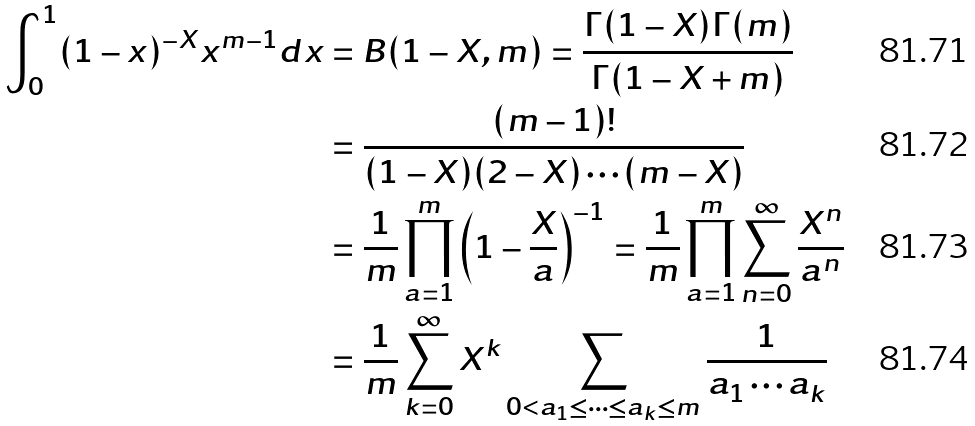<formula> <loc_0><loc_0><loc_500><loc_500>\int _ { 0 } ^ { 1 } ( 1 - x ) ^ { - X } x ^ { m - 1 } d x & = B ( 1 - X , m ) = \frac { \Gamma ( 1 - X ) \Gamma ( m ) } { \Gamma ( 1 - X + m ) } \\ & = \frac { ( m - 1 ) ! } { ( 1 - X ) ( 2 - X ) \cdots ( m - X ) } \\ & = \frac { 1 } { m } \prod _ { a = 1 } ^ { m } \left ( 1 - \frac { X } { a } \right ) ^ { - 1 } = \frac { 1 } { m } \prod _ { a = 1 } ^ { m } \sum _ { n = 0 } ^ { \infty } \frac { X ^ { n } } { a ^ { n } } \\ & = \frac { 1 } { m } \sum _ { k = 0 } ^ { \infty } X ^ { k } \sum _ { 0 < a _ { 1 } \leq \cdots \leq a _ { k } \leq m } \frac { 1 } { a _ { 1 } \cdots a _ { k } }</formula> 